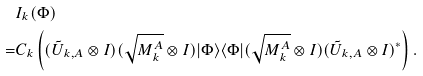<formula> <loc_0><loc_0><loc_500><loc_500>& I _ { k } ( \Phi ) \\ = & C _ { k } \left ( ( \tilde { U } _ { k , A } \otimes I ) ( \sqrt { M _ { k } ^ { A } } \otimes I ) | \Phi \rangle \langle \Phi | ( \sqrt { M _ { k } ^ { A } } \otimes I ) ( \tilde { U } _ { k , A } \otimes I ) ^ { * } \right ) .</formula> 